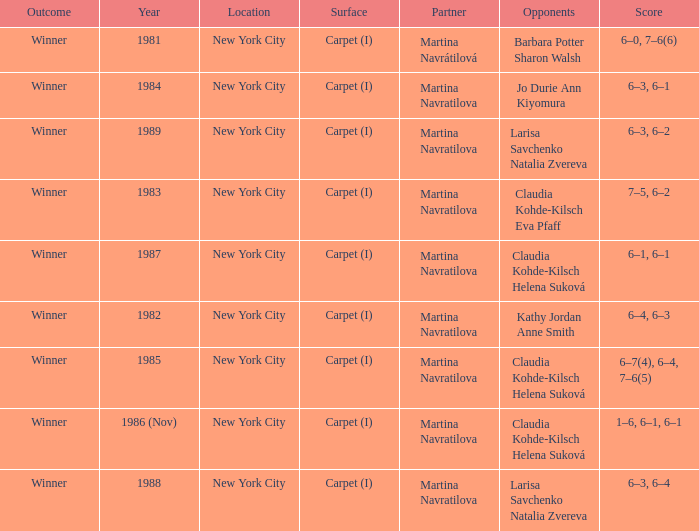How many partners were there in 1988? 1.0. 